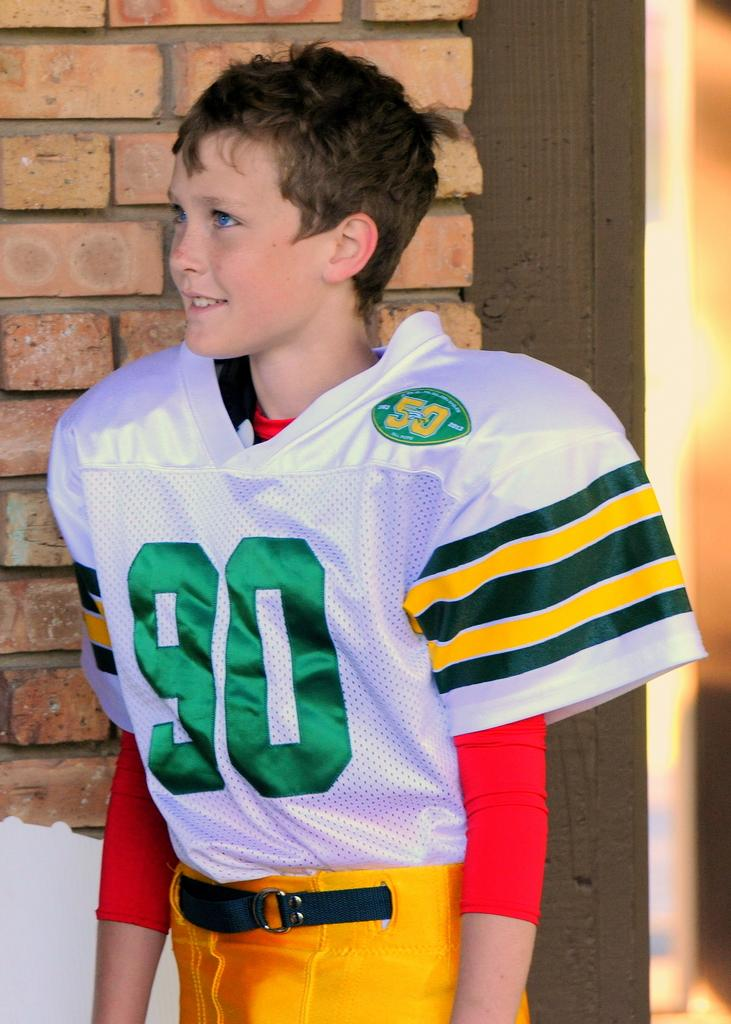<image>
Give a short and clear explanation of the subsequent image. A young boy in a football jersey wears a green number 90 in full uniform. 